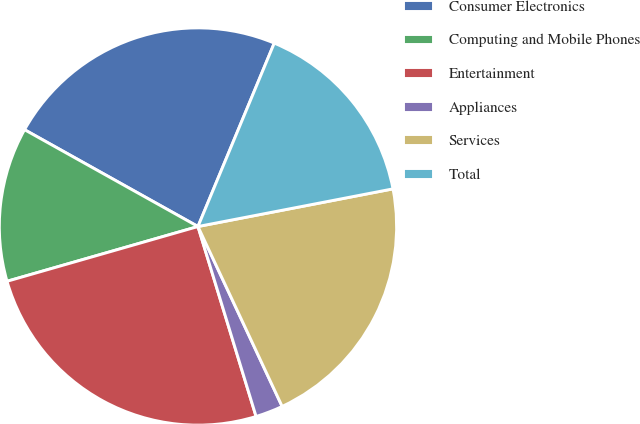Convert chart. <chart><loc_0><loc_0><loc_500><loc_500><pie_chart><fcel>Consumer Electronics<fcel>Computing and Mobile Phones<fcel>Entertainment<fcel>Appliances<fcel>Services<fcel>Total<nl><fcel>23.17%<fcel>12.55%<fcel>25.28%<fcel>2.24%<fcel>21.07%<fcel>15.69%<nl></chart> 